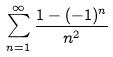Convert formula to latex. <formula><loc_0><loc_0><loc_500><loc_500>\sum _ { n = 1 } ^ { \infty } \frac { 1 - ( - 1 ) ^ { n } } { n ^ { 2 } }</formula> 